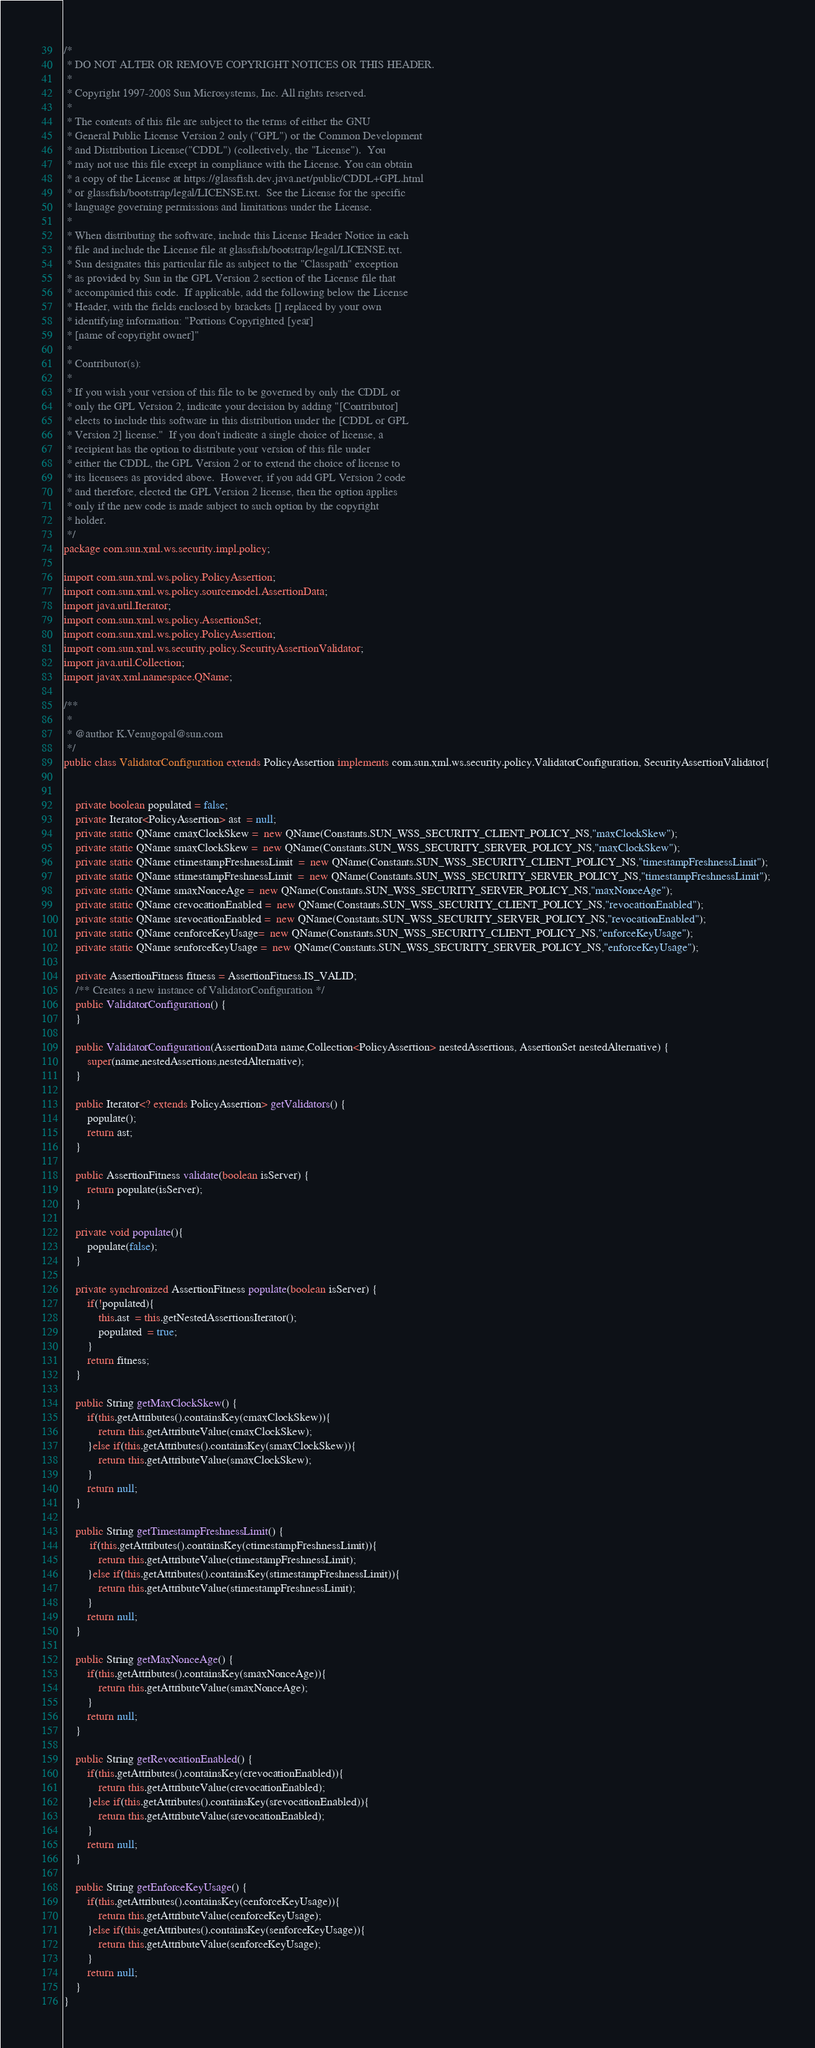Convert code to text. <code><loc_0><loc_0><loc_500><loc_500><_Java_>/*
 * DO NOT ALTER OR REMOVE COPYRIGHT NOTICES OR THIS HEADER.
 * 
 * Copyright 1997-2008 Sun Microsystems, Inc. All rights reserved.
 * 
 * The contents of this file are subject to the terms of either the GNU
 * General Public License Version 2 only ("GPL") or the Common Development
 * and Distribution License("CDDL") (collectively, the "License").  You
 * may not use this file except in compliance with the License. You can obtain
 * a copy of the License at https://glassfish.dev.java.net/public/CDDL+GPL.html
 * or glassfish/bootstrap/legal/LICENSE.txt.  See the License for the specific
 * language governing permissions and limitations under the License.
 * 
 * When distributing the software, include this License Header Notice in each
 * file and include the License file at glassfish/bootstrap/legal/LICENSE.txt.
 * Sun designates this particular file as subject to the "Classpath" exception
 * as provided by Sun in the GPL Version 2 section of the License file that
 * accompanied this code.  If applicable, add the following below the License
 * Header, with the fields enclosed by brackets [] replaced by your own
 * identifying information: "Portions Copyrighted [year]
 * [name of copyright owner]"
 * 
 * Contributor(s):
 * 
 * If you wish your version of this file to be governed by only the CDDL or
 * only the GPL Version 2, indicate your decision by adding "[Contributor]
 * elects to include this software in this distribution under the [CDDL or GPL
 * Version 2] license."  If you don't indicate a single choice of license, a
 * recipient has the option to distribute your version of this file under
 * either the CDDL, the GPL Version 2 or to extend the choice of license to
 * its licensees as provided above.  However, if you add GPL Version 2 code
 * and therefore, elected the GPL Version 2 license, then the option applies
 * only if the new code is made subject to such option by the copyright
 * holder.
 */
package com.sun.xml.ws.security.impl.policy;

import com.sun.xml.ws.policy.PolicyAssertion;
import com.sun.xml.ws.policy.sourcemodel.AssertionData;
import java.util.Iterator;
import com.sun.xml.ws.policy.AssertionSet;
import com.sun.xml.ws.policy.PolicyAssertion;
import com.sun.xml.ws.security.policy.SecurityAssertionValidator;
import java.util.Collection;
import javax.xml.namespace.QName;

/**
 *
 * @author K.Venugopal@sun.com
 */
public class ValidatorConfiguration extends PolicyAssertion implements com.sun.xml.ws.security.policy.ValidatorConfiguration, SecurityAssertionValidator{
    
    
    private boolean populated = false;
    private Iterator<PolicyAssertion> ast  = null;
    private static QName cmaxClockSkew =  new QName(Constants.SUN_WSS_SECURITY_CLIENT_POLICY_NS,"maxClockSkew");
    private static QName smaxClockSkew =  new QName(Constants.SUN_WSS_SECURITY_SERVER_POLICY_NS,"maxClockSkew");
    private static QName ctimestampFreshnessLimit  =  new QName(Constants.SUN_WSS_SECURITY_CLIENT_POLICY_NS,"timestampFreshnessLimit");
    private static QName stimestampFreshnessLimit  =  new QName(Constants.SUN_WSS_SECURITY_SERVER_POLICY_NS,"timestampFreshnessLimit"); 
    private static QName smaxNonceAge =  new QName(Constants.SUN_WSS_SECURITY_SERVER_POLICY_NS,"maxNonceAge");
    private static QName crevocationEnabled =  new QName(Constants.SUN_WSS_SECURITY_CLIENT_POLICY_NS,"revocationEnabled");
    private static QName srevocationEnabled =  new QName(Constants.SUN_WSS_SECURITY_SERVER_POLICY_NS,"revocationEnabled");
    private static QName cenforceKeyUsage=  new QName(Constants.SUN_WSS_SECURITY_CLIENT_POLICY_NS,"enforceKeyUsage");
    private static QName senforceKeyUsage =  new QName(Constants.SUN_WSS_SECURITY_SERVER_POLICY_NS,"enforceKeyUsage");
    
    private AssertionFitness fitness = AssertionFitness.IS_VALID;
    /** Creates a new instance of ValidatorConfiguration */
    public ValidatorConfiguration() {
    }
    
    public ValidatorConfiguration(AssertionData name,Collection<PolicyAssertion> nestedAssertions, AssertionSet nestedAlternative) {
        super(name,nestedAssertions,nestedAlternative);
    }
    
    public Iterator<? extends PolicyAssertion> getValidators() {
        populate();
        return ast;
    }
    
    public AssertionFitness validate(boolean isServer) {
        return populate(isServer);
    }
    
    private void populate(){
        populate(false);
    }
    
    private synchronized AssertionFitness populate(boolean isServer) {        
        if(!populated){
            this.ast  = this.getNestedAssertionsIterator();
            populated  = true;
        }
        return fitness;        
    }
    
    public String getMaxClockSkew() {       
        if(this.getAttributes().containsKey(cmaxClockSkew)){
            return this.getAttributeValue(cmaxClockSkew);
        }else if(this.getAttributes().containsKey(smaxClockSkew)){
            return this.getAttributeValue(smaxClockSkew);
        }
        return null;
    }
    
    public String getTimestampFreshnessLimit() {
         if(this.getAttributes().containsKey(ctimestampFreshnessLimit)){
            return this.getAttributeValue(ctimestampFreshnessLimit);
        }else if(this.getAttributes().containsKey(stimestampFreshnessLimit)){
            return this.getAttributeValue(stimestampFreshnessLimit);
        }
        return null;        
    }
    
    public String getMaxNonceAge() {
        if(this.getAttributes().containsKey(smaxNonceAge)){
            return this.getAttributeValue(smaxNonceAge);
        }
        return null;            
    }

    public String getRevocationEnabled() {
        if(this.getAttributes().containsKey(crevocationEnabled)){
            return this.getAttributeValue(crevocationEnabled);
        }else if(this.getAttributes().containsKey(srevocationEnabled)){
            return this.getAttributeValue(srevocationEnabled);
        }
        return null;
    }
    
    public String getEnforceKeyUsage() {
        if(this.getAttributes().containsKey(cenforceKeyUsage)){
            return this.getAttributeValue(cenforceKeyUsage);
        }else if(this.getAttributes().containsKey(senforceKeyUsage)){
            return this.getAttributeValue(senforceKeyUsage);
        }
        return null;
    }
}
</code> 